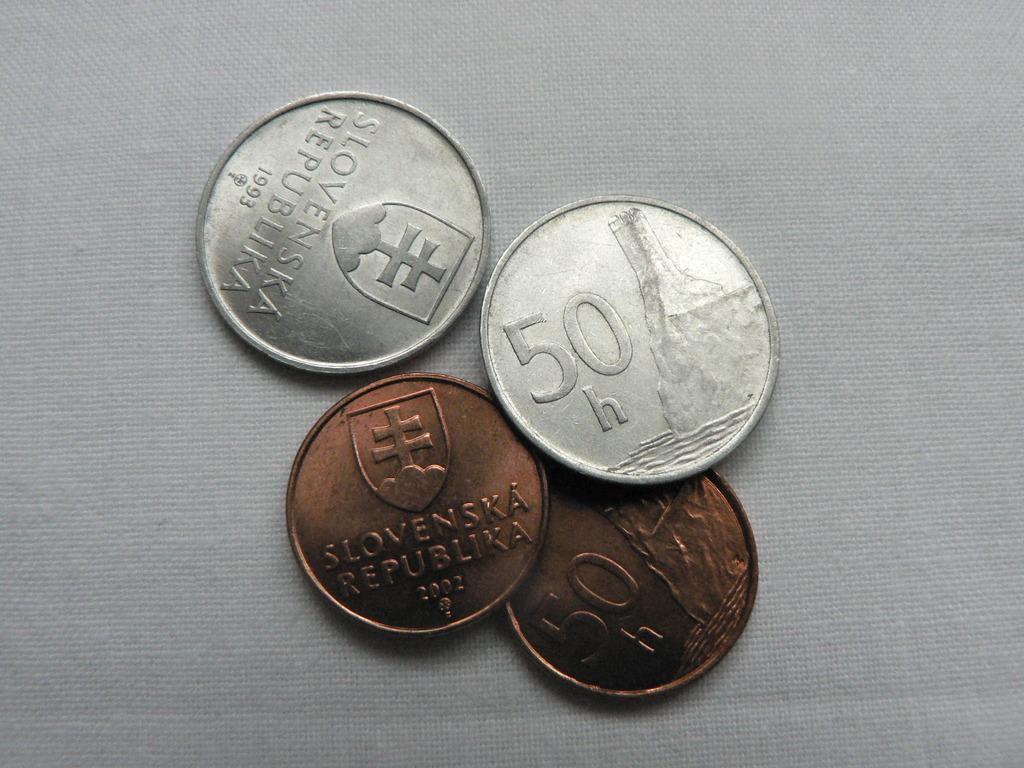What year is the top silver coin?
Keep it short and to the point. 1993. 